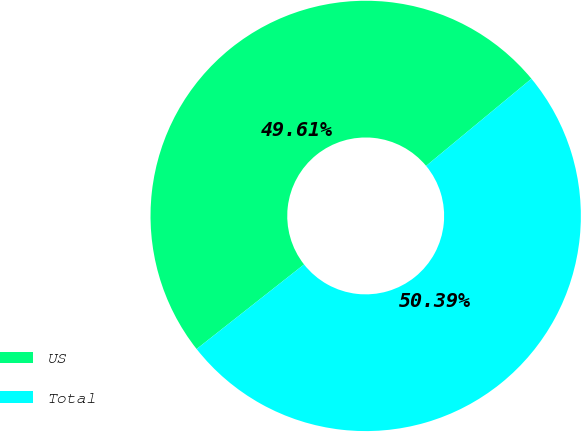<chart> <loc_0><loc_0><loc_500><loc_500><pie_chart><fcel>US<fcel>Total<nl><fcel>49.61%<fcel>50.39%<nl></chart> 